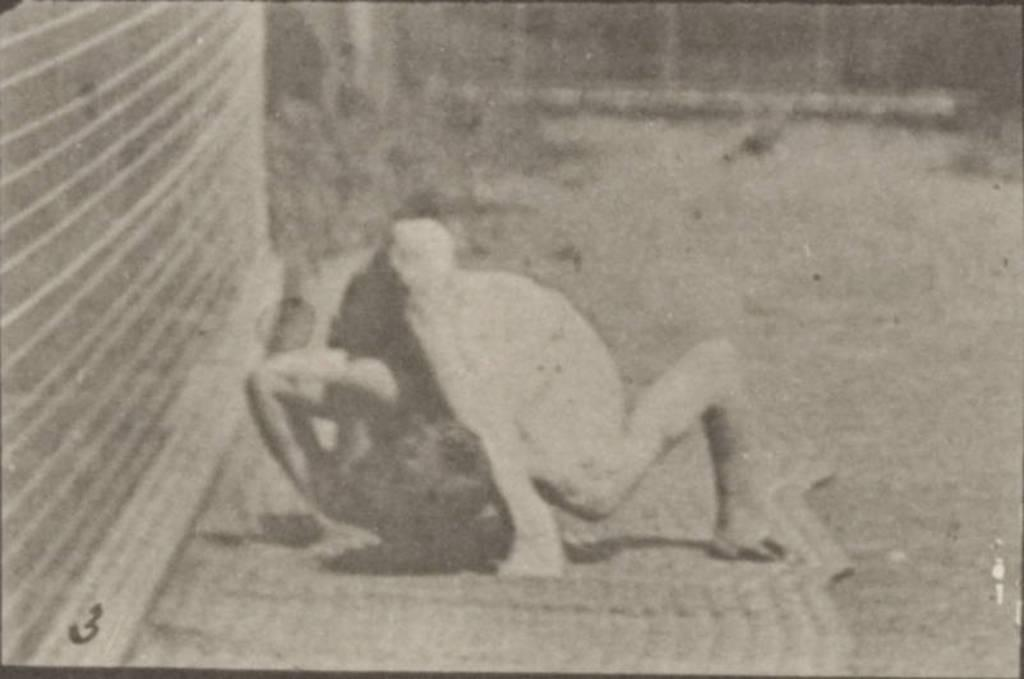What activity is the human performing in the picture? The human is performing gymnastics in the picture. What else can be seen in the picture besides the gymnast? There are plants visible in the picture. What is located on the left side of the picture? There is a wall on the left side of the picture. What type of train can be seen passing by in the picture? There is no train present in the picture; it features a human performing gymnastics and plants. What kind of quilt is being used by the gymnast in the picture? There is no quilt visible in the picture; the gymnast is not using any quilt. 